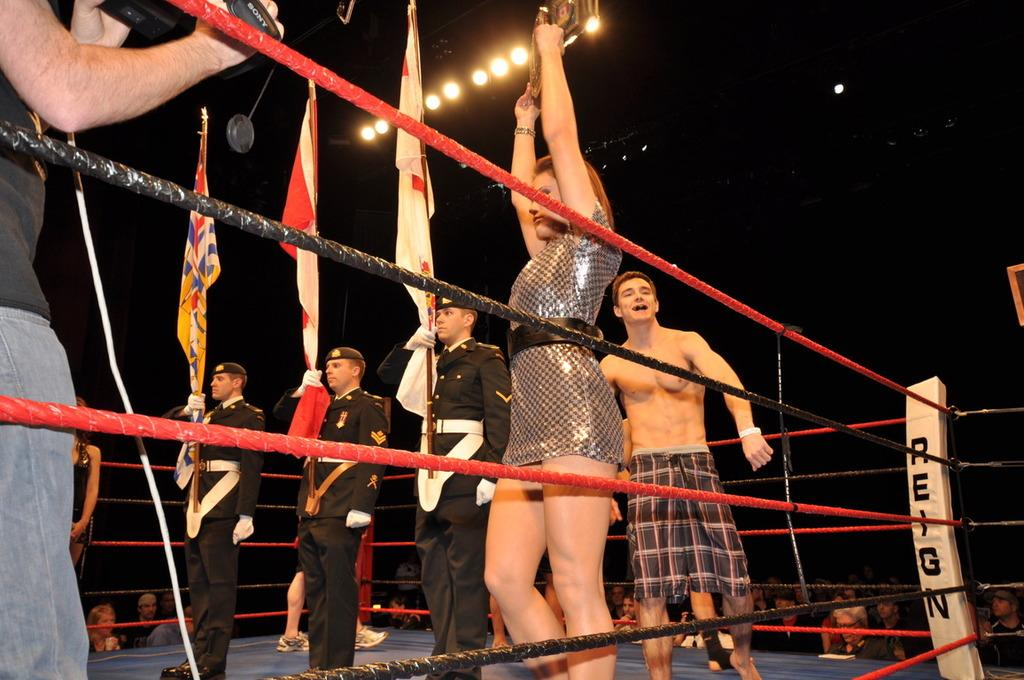<image>
Render a clear and concise summary of the photo. A group of people stand in a boxing ring with the word Reign. 